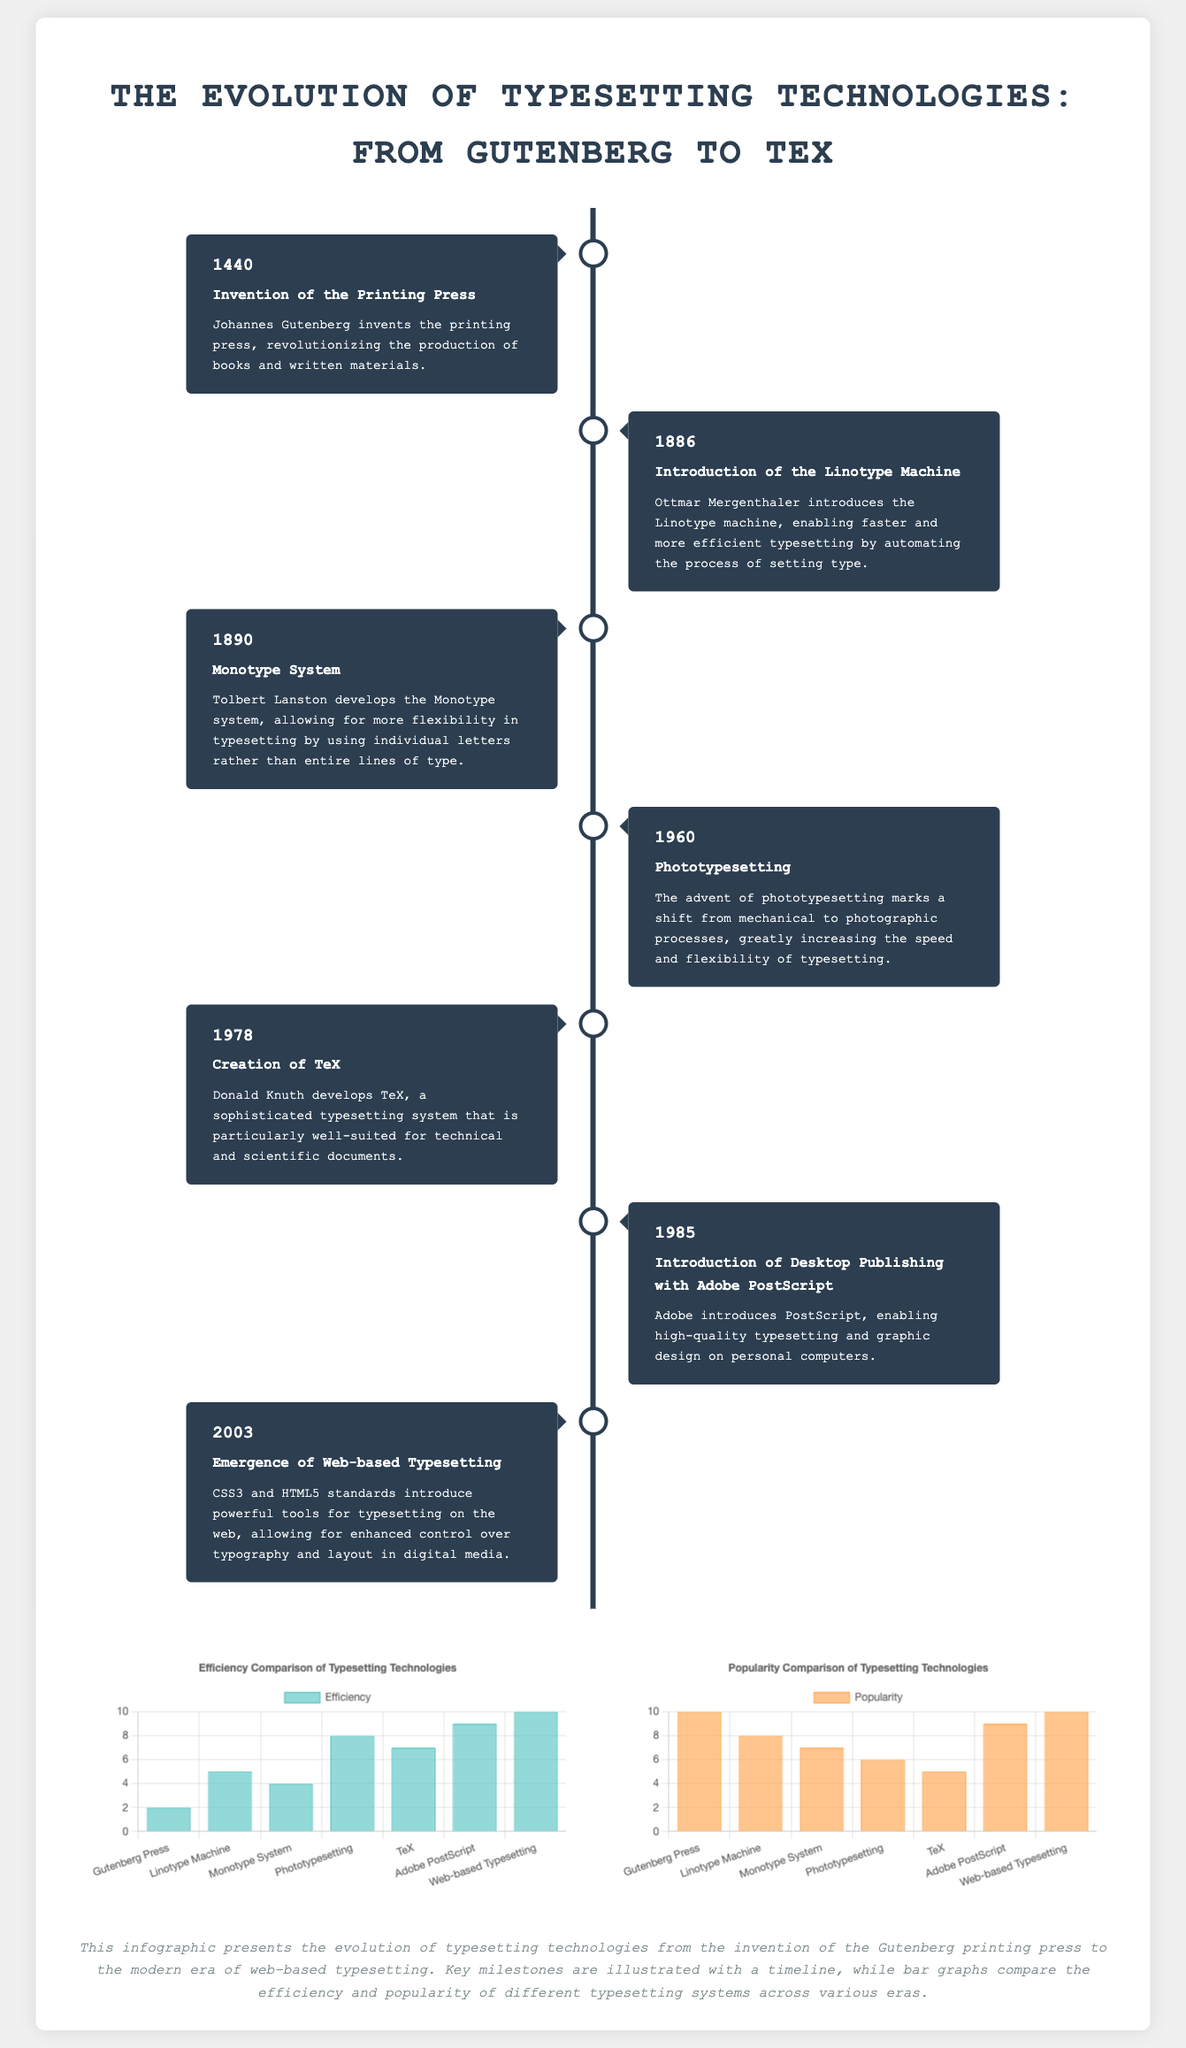What year was the printing press invented? The year of the invention of the printing press is mentioned in the timeline section of the document as 1440.
Answer: 1440 Who introduced the Linotype machine? The document states that Ottmar Mergenthaler introduced the Linotype machine in 1886.
Answer: Ottmar Mergenthaler What is the description of TeX? The description of TeX is provided in the context of its creation in 1978, highlighting its suitability for technical and scientific documents.
Answer: A sophisticated typesetting system How many milestones are featured in the timeline? The timeline in the document lists seven key milestones in the evolution of typesetting technologies.
Answer: Seven What is the efficiency score of web-based typesetting? The efficiency chart indicates that the efficiency score for web-based typesetting is 10.
Answer: 10 What does the efficiency comparison chart illustrate? The efficiency comparison chart illustrates the efficiency of different typesetting technologies over the years, highlighting improvements through the timeline.
Answer: Efficiency of different technologies Which typesetting technology has the highest popularity score? According to the popularity chart, the Gutenberg Press and web-based typesetting both have the highest popularity score of 10.
Answer: 10 What year marks the introduction of Adobe PostScript? The document shows that Adobe PostScript was introduced in 1985 within the timeline of typesetting technologies.
Answer: 1985 What transition does phototypesetting represent? The document notes that phototypesetting marks a shift from mechanical to photographic typesetting processes.
Answer: Shift to photographic processes 